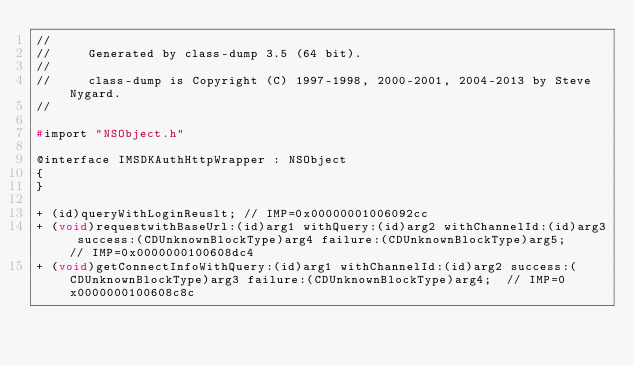<code> <loc_0><loc_0><loc_500><loc_500><_C_>//
//     Generated by class-dump 3.5 (64 bit).
//
//     class-dump is Copyright (C) 1997-1998, 2000-2001, 2004-2013 by Steve Nygard.
//

#import "NSObject.h"

@interface IMSDKAuthHttpWrapper : NSObject
{
}

+ (id)queryWithLoginReuslt;	// IMP=0x00000001006092cc
+ (void)requestwithBaseUrl:(id)arg1 withQuery:(id)arg2 withChannelId:(id)arg3 success:(CDUnknownBlockType)arg4 failure:(CDUnknownBlockType)arg5;	// IMP=0x0000000100608dc4
+ (void)getConnectInfoWithQuery:(id)arg1 withChannelId:(id)arg2 success:(CDUnknownBlockType)arg3 failure:(CDUnknownBlockType)arg4;	// IMP=0x0000000100608c8c</code> 